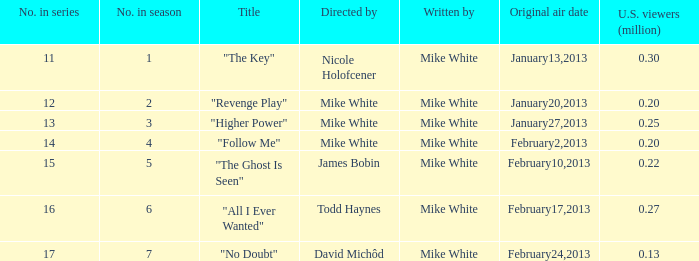Who directed the episode that garnered Mike White. 